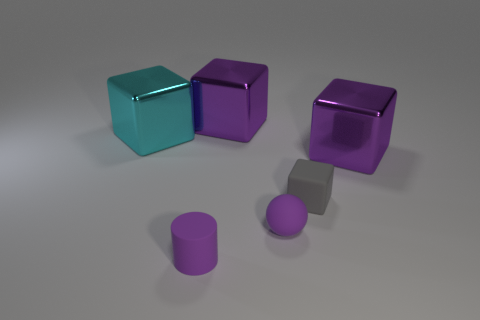Subtract all large metallic cubes. How many cubes are left? 1 Subtract 1 cubes. How many cubes are left? 3 Subtract all cyan blocks. How many blocks are left? 3 Subtract all brown cubes. Subtract all brown spheres. How many cubes are left? 4 Add 1 cyan metal objects. How many objects exist? 7 Subtract all balls. How many objects are left? 5 Add 1 small gray rubber things. How many small gray rubber things exist? 2 Subtract 1 purple balls. How many objects are left? 5 Subtract all tiny brown cylinders. Subtract all small purple matte cylinders. How many objects are left? 5 Add 3 purple balls. How many purple balls are left? 4 